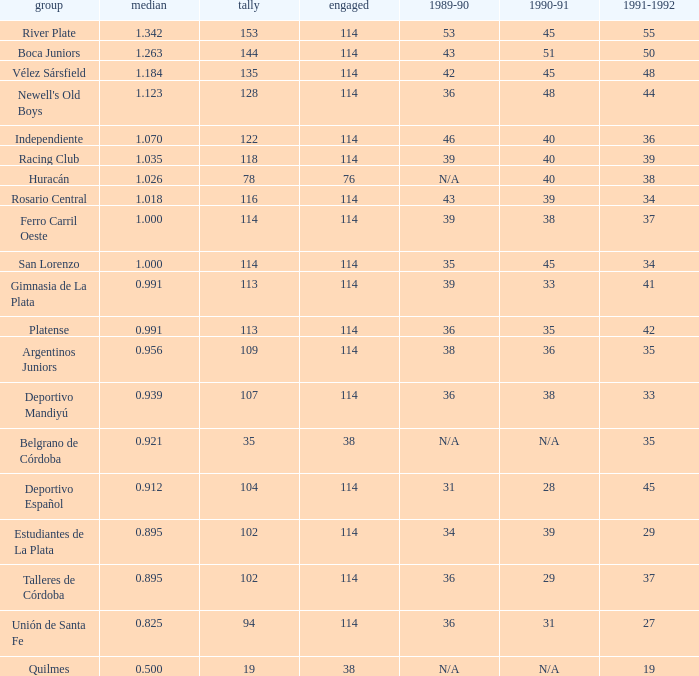How much 1991-1992 has a Team of gimnasia de la plata, and more than 113 points? 0.0. 